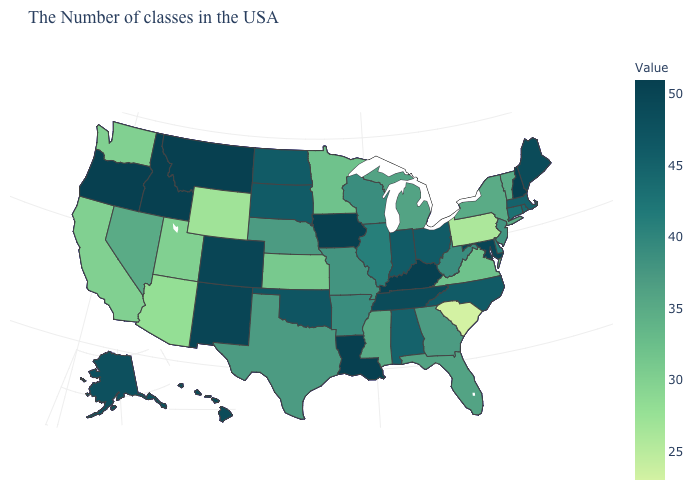Which states have the highest value in the USA?
Be succinct. New Hampshire, Kentucky, Louisiana, Iowa, Montana, Idaho, Oregon. Which states have the lowest value in the MidWest?
Quick response, please. Kansas. Which states have the lowest value in the USA?
Quick response, please. South Carolina. Which states have the lowest value in the MidWest?
Quick response, please. Kansas. 